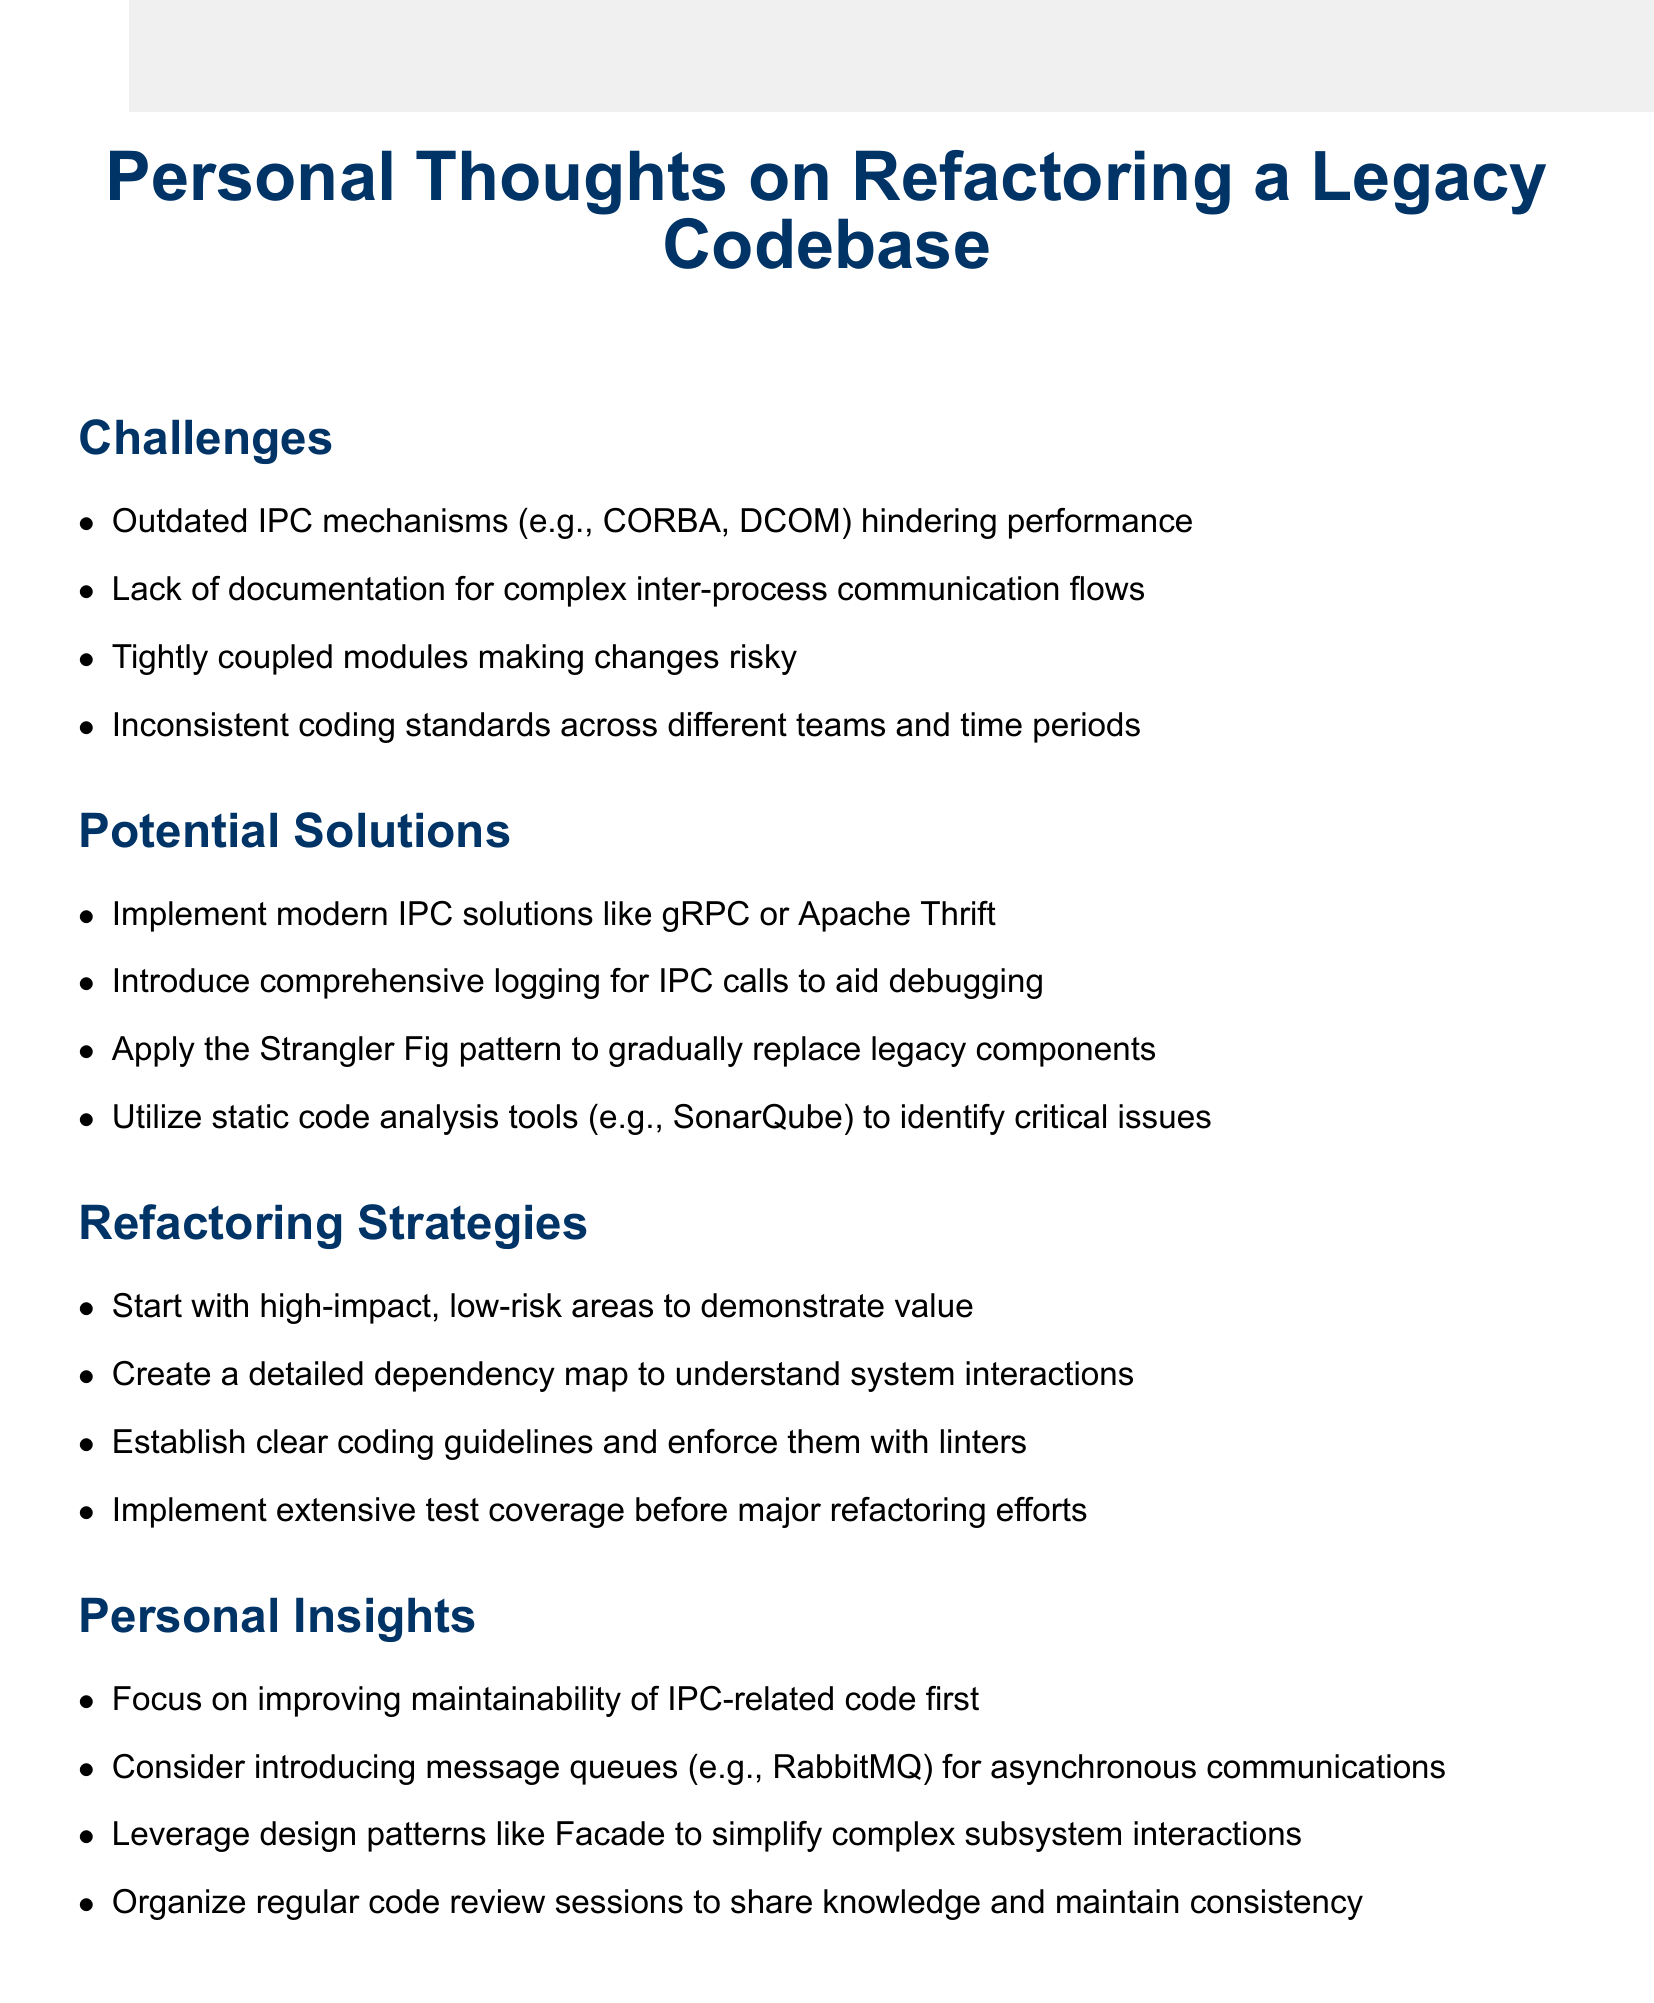What is the title of the document? The title is stated at the beginning of the document in a prominent format.
Answer: Personal Thoughts on Refactoring a Legacy Codebase How many challenges are listed in the document? The number of challenges can be counted from the section titled "Challenges."
Answer: Four What IPC mechanism is suggested to implement for modern solutions? The suggested modern IPC solutions can be found in the "Potential Solutions" section.
Answer: gRPC Which design pattern is mentioned to simplify complex subsystem interactions? The document lists various design patterns in the "Personal Insights" section, including one that simplifies interactions.
Answer: Facade What must be created to understand system interactions? The document emphasizes the importance of a certain map in the "Refactoring Strategies" section.
Answer: Detailed dependency map What is the focus of the first personal insight? This insight is specifically aimed at improving a particular aspect of the code.
Answer: Improving maintainability of IPC-related code Which tool is recommended for identifying critical issues? The recommendation can be found in the "Potential Solutions" section, stating a tool to utilize for analysis.
Answer: SonarQube 